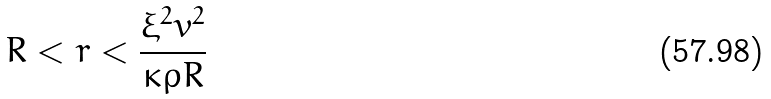Convert formula to latex. <formula><loc_0><loc_0><loc_500><loc_500>R < r < \frac { \xi ^ { 2 } v ^ { 2 } } { \kappa \rho R }</formula> 